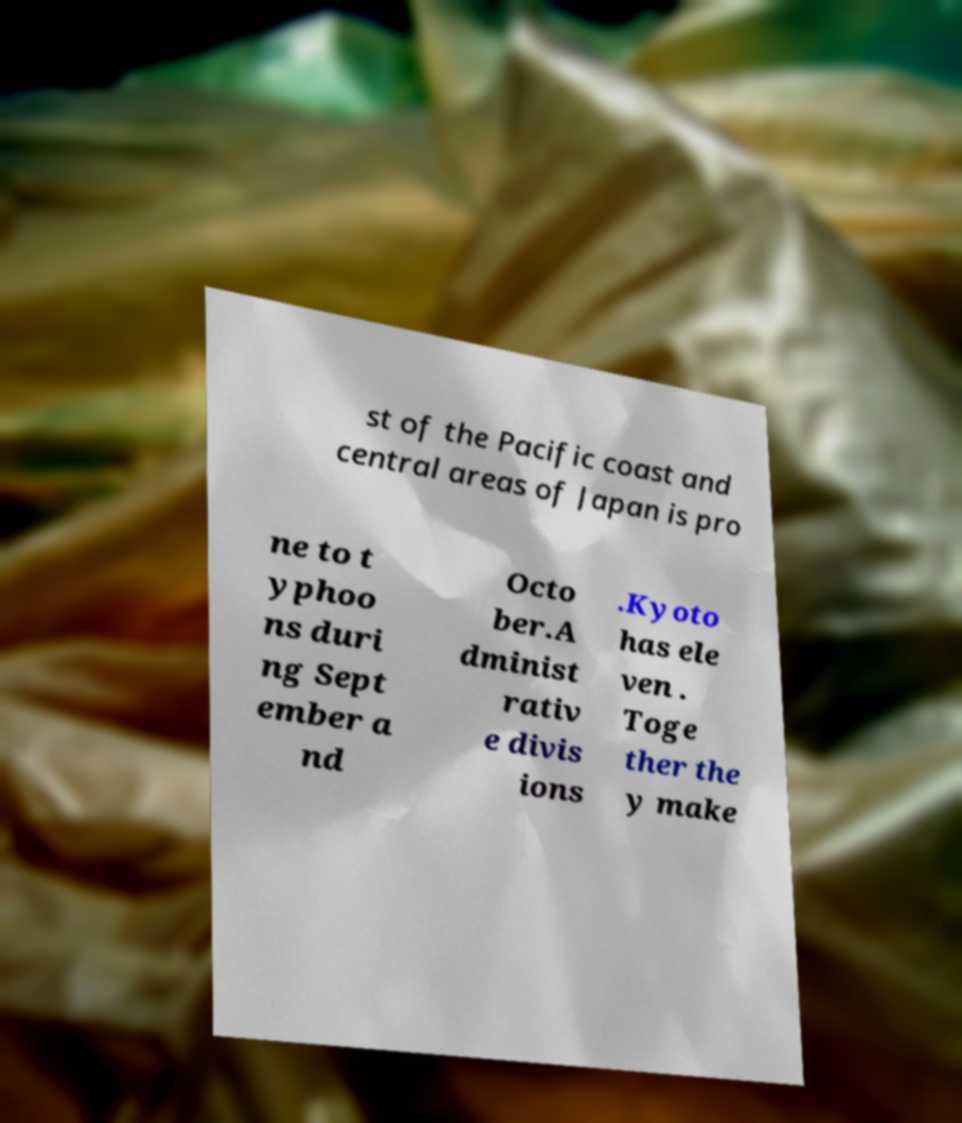There's text embedded in this image that I need extracted. Can you transcribe it verbatim? st of the Pacific coast and central areas of Japan is pro ne to t yphoo ns duri ng Sept ember a nd Octo ber.A dminist rativ e divis ions .Kyoto has ele ven . Toge ther the y make 